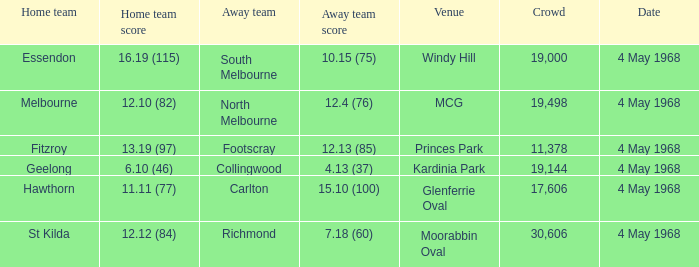What team played at Moorabbin Oval to a crowd of 19,144? St Kilda. 